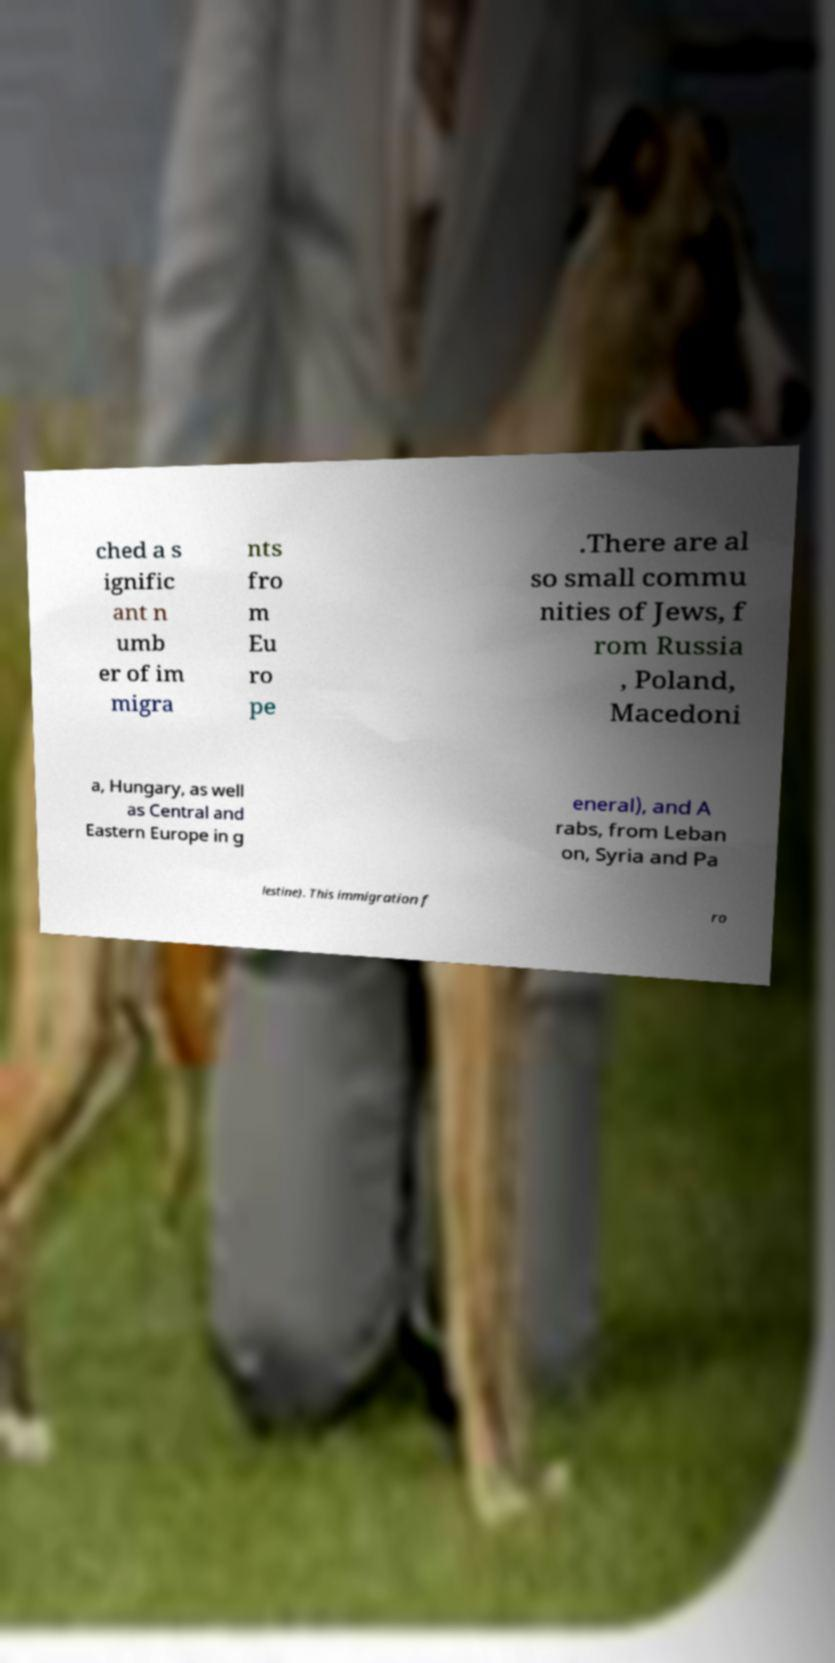There's text embedded in this image that I need extracted. Can you transcribe it verbatim? ched a s ignific ant n umb er of im migra nts fro m Eu ro pe .There are al so small commu nities of Jews, f rom Russia , Poland, Macedoni a, Hungary, as well as Central and Eastern Europe in g eneral), and A rabs, from Leban on, Syria and Pa lestine). This immigration f ro 